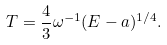<formula> <loc_0><loc_0><loc_500><loc_500>T = \frac { 4 } { 3 } \omega ^ { - 1 } ( E - a ) ^ { 1 / 4 } .</formula> 